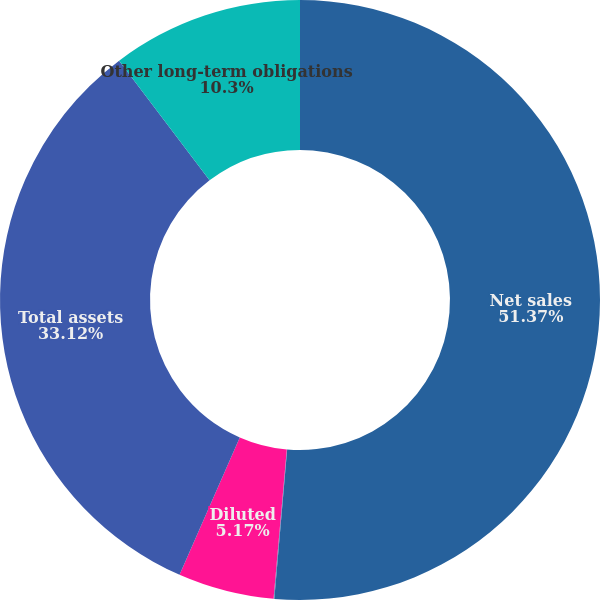Convert chart to OTSL. <chart><loc_0><loc_0><loc_500><loc_500><pie_chart><fcel>Net sales<fcel>Basic<fcel>Diluted<fcel>Total assets<fcel>Other long-term obligations<nl><fcel>51.36%<fcel>0.04%<fcel>5.17%<fcel>33.12%<fcel>10.3%<nl></chart> 